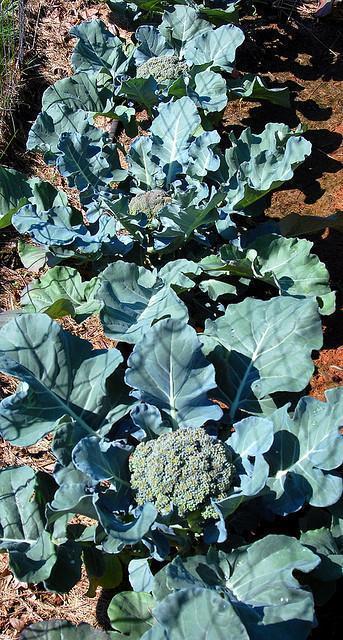How many cats are shown?
Give a very brief answer. 0. 